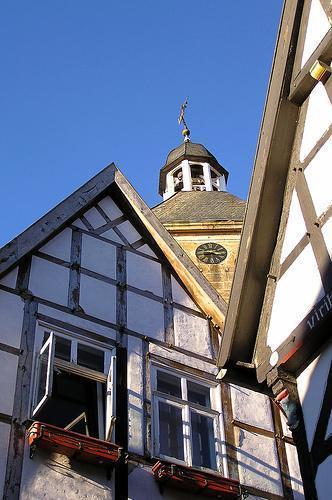How many people are jumping from the open window ?
Give a very brief answer. 0. 